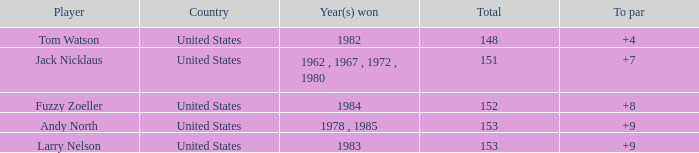What is Andy North with a To par greater than 8 Country? United States. 